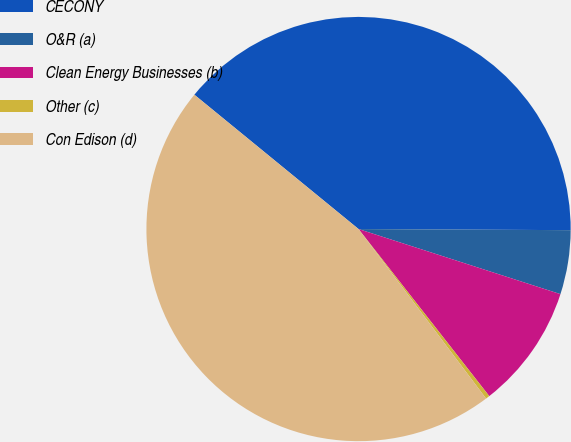<chart> <loc_0><loc_0><loc_500><loc_500><pie_chart><fcel>CECONY<fcel>O&R (a)<fcel>Clean Energy Businesses (b)<fcel>Other (c)<fcel>Con Edison (d)<nl><fcel>39.17%<fcel>4.88%<fcel>9.47%<fcel>0.3%<fcel>46.18%<nl></chart> 